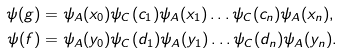Convert formula to latex. <formula><loc_0><loc_0><loc_500><loc_500>\psi ( g ) & = \psi _ { A } ( x _ { 0 } ) \psi _ { C } ( c _ { 1 } ) \psi _ { A } ( x _ { 1 } ) \dots \psi _ { C } ( c _ { n } ) \psi _ { A } ( x _ { n } ) , \\ \psi ( f ) & = \psi _ { A } ( y _ { 0 } ) \psi _ { C } ( d _ { 1 } ) \psi _ { A } ( y _ { 1 } ) \dots \psi _ { C } ( d _ { n } ) \psi _ { A } ( y _ { n } ) .</formula> 